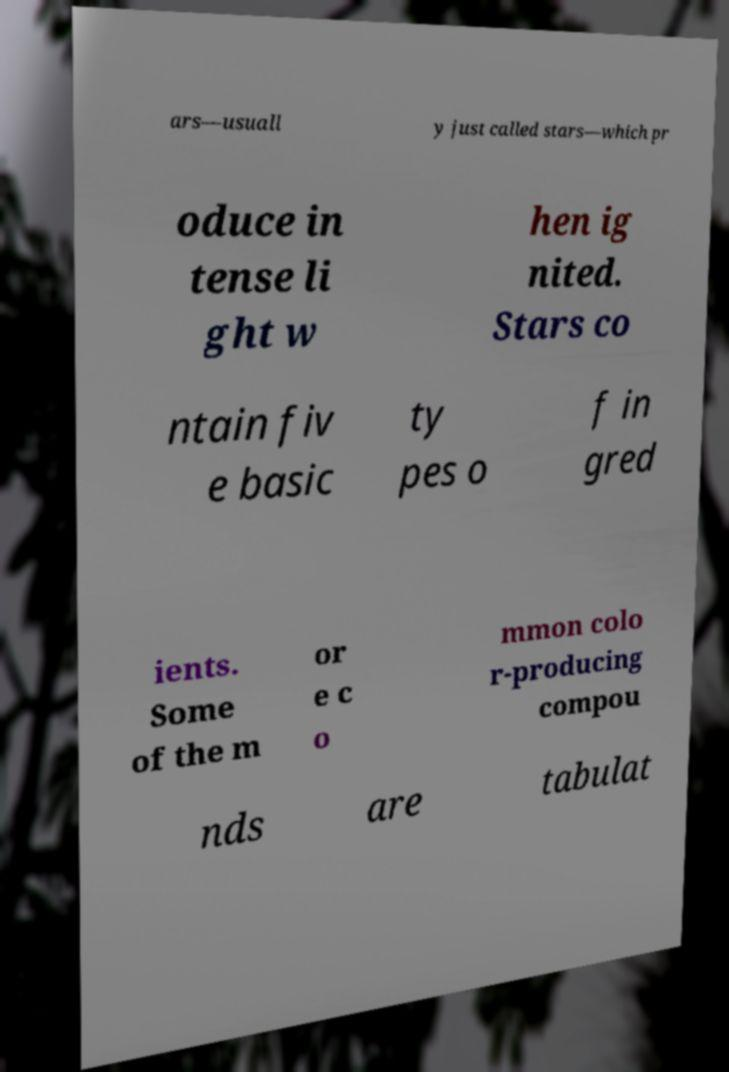There's text embedded in this image that I need extracted. Can you transcribe it verbatim? ars—usuall y just called stars—which pr oduce in tense li ght w hen ig nited. Stars co ntain fiv e basic ty pes o f in gred ients. Some of the m or e c o mmon colo r-producing compou nds are tabulat 